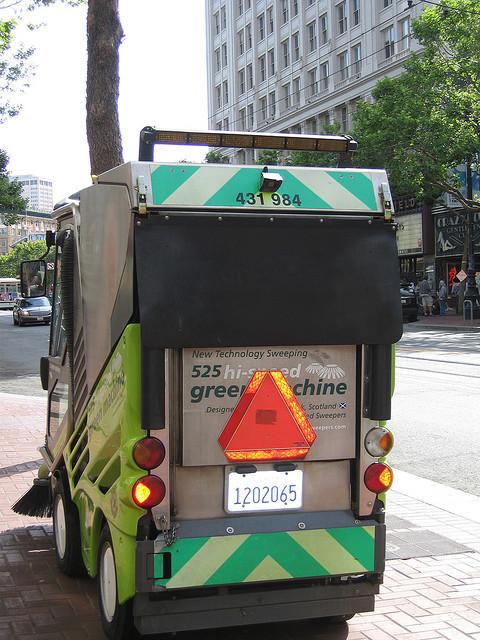Where is the safety triangle?
Write a very short answer. Back of truck. What is the license plate number on the vehicle?
Concise answer only. 1202065. What type of vehicle is this?
Keep it brief. Street sweeper. 